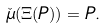<formula> <loc_0><loc_0><loc_500><loc_500>\check { \mu } ( \Xi ( P ) ) = P .</formula> 